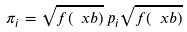Convert formula to latex. <formula><loc_0><loc_0><loc_500><loc_500>\pi _ { i } = \sqrt { f ( \ x b ) } \, p _ { i } \sqrt { f ( \ x b ) }</formula> 